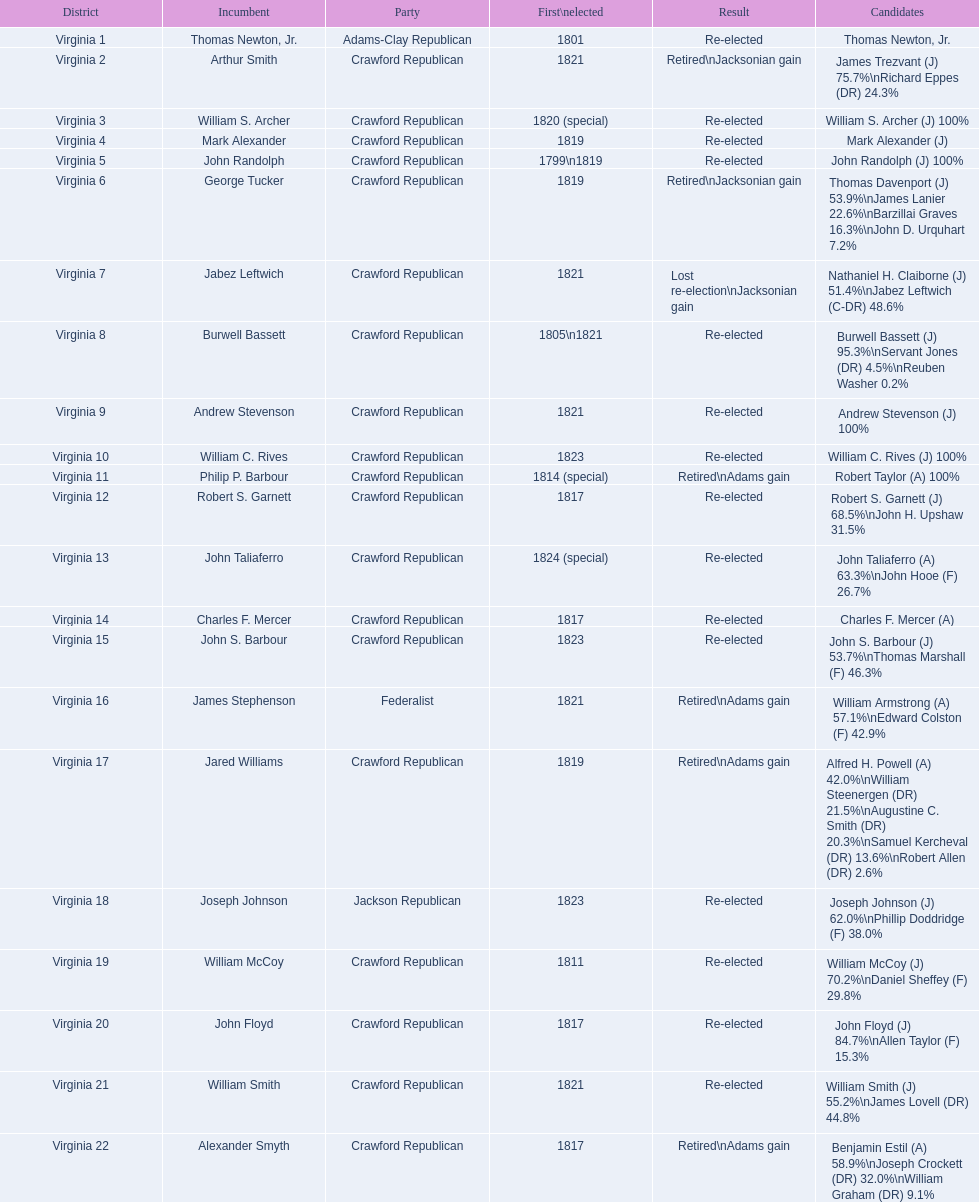Can you identify the incumbents associated with the crawford republican party? Arthur Smith, William S. Archer, Mark Alexander, John Randolph, George Tucker, Jabez Leftwich, Burwell Bassett, Andrew Stevenson, William C. Rives, Philip P. Barbour, Robert S. Garnett, John Taliaferro, Charles F. Mercer, John S. Barbour, Jared Williams, William McCoy, John Floyd, William Smith, Alexander Smyth. Who among them initially won their election in 1821? Arthur Smith, Jabez Leftwich, Andrew Stevenson, William Smith. Do any of these incumbents share the last name smith? Arthur Smith, William Smith. Which of the two did not manage to get re-elected? Arthur Smith. 